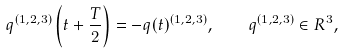<formula> <loc_0><loc_0><loc_500><loc_500>q ^ { ( 1 , 2 , 3 ) } \left ( t + \frac { T } { 2 } \right ) = - q ( t ) ^ { ( 1 , 2 , 3 ) } , \quad q ^ { ( 1 , 2 , 3 ) } \in R ^ { 3 } ,</formula> 